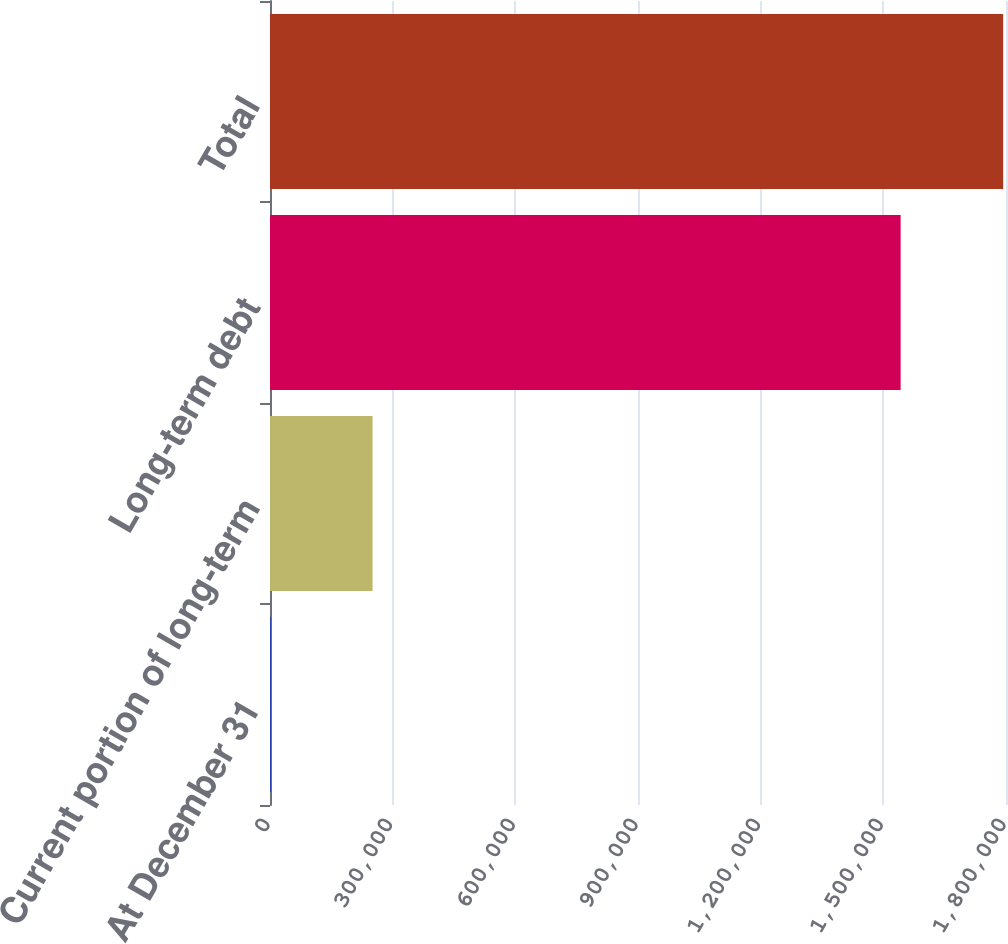<chart> <loc_0><loc_0><loc_500><loc_500><bar_chart><fcel>At December 31<fcel>Current portion of long-term<fcel>Long-term debt<fcel>Total<nl><fcel>2014<fcel>250805<fcel>1.54232e+06<fcel>1.79312e+06<nl></chart> 